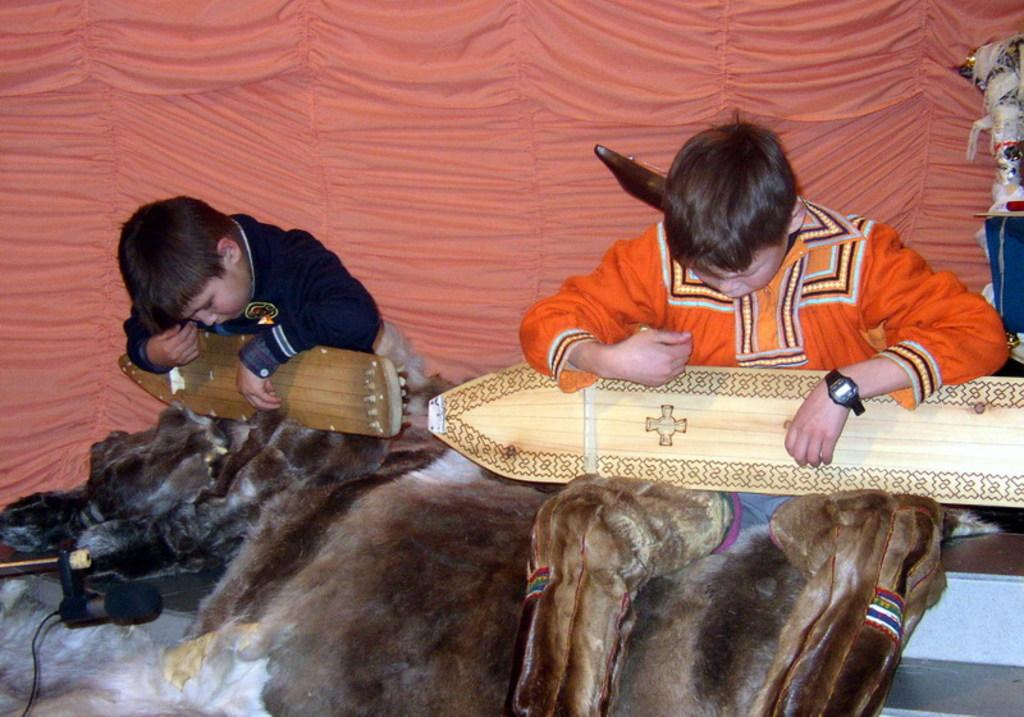How many boys are in the image? There are two boys in the image. What are the boys doing in the image? The boys are sitting in the image. What are the boys holding in their hands? The boys are holding wooden objects in the image. What can be seen in the background of the image? There is a curtain in the background of the image. Where is the microphone located in the image? The microphone is on the left side bottom of the image. What book are the boys reading in the image? There is no book present in the image, and the boys are not reading. What type of string is attached to the wooden objects the boys are holding? There is no string attached to the wooden objects the boys are holding in the image. 